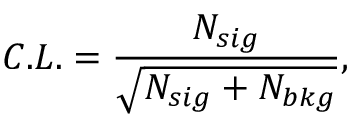<formula> <loc_0><loc_0><loc_500><loc_500>C . L . = \frac { N _ { s i g } } { \sqrt { N _ { s i g } + N _ { b k g } } } ,</formula> 